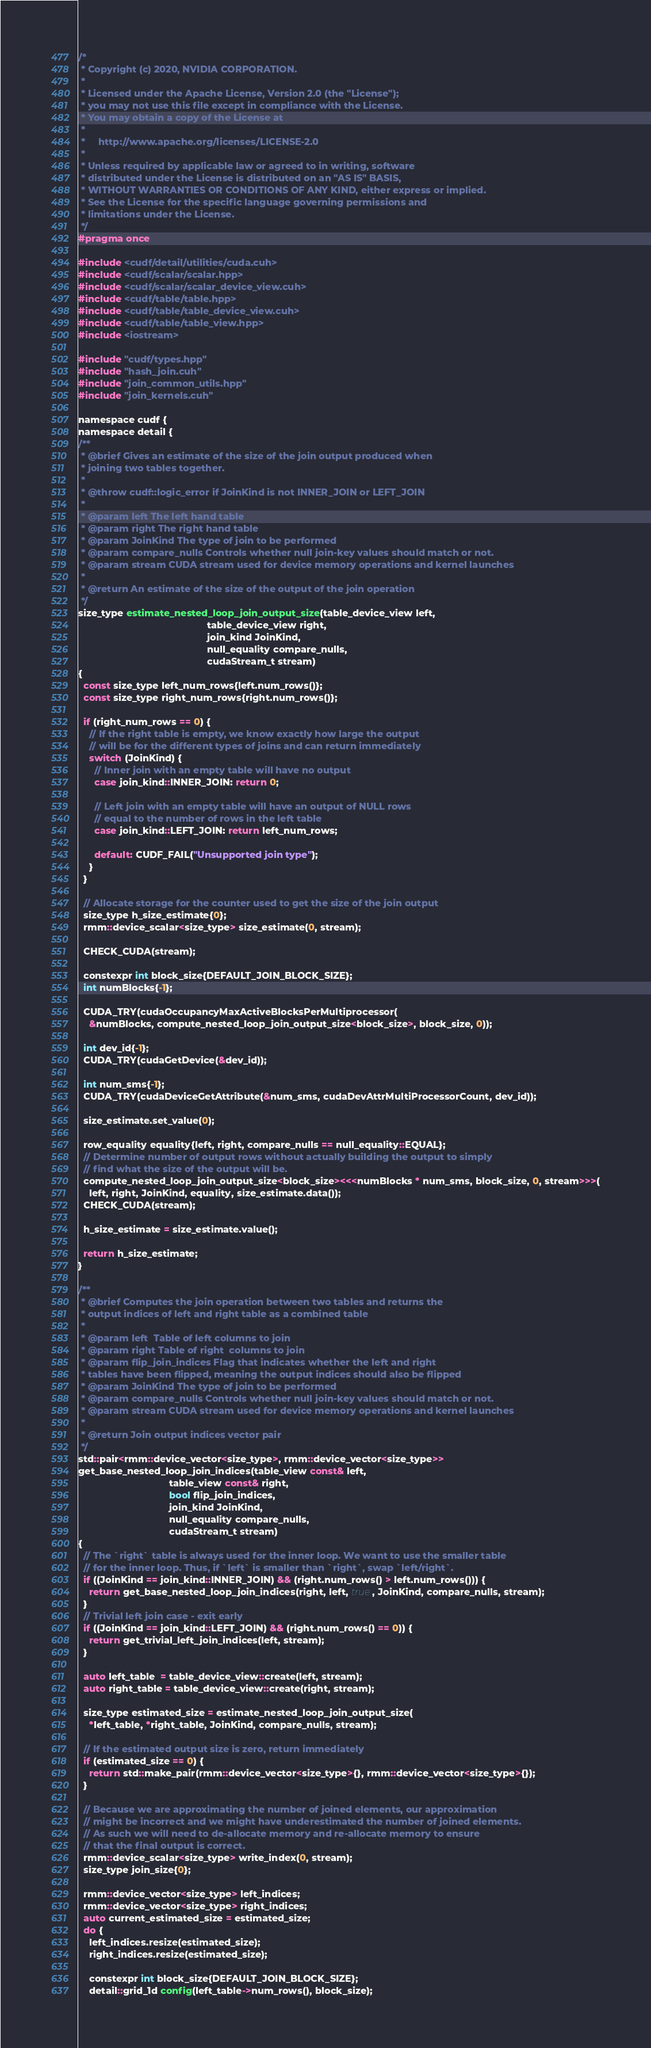Convert code to text. <code><loc_0><loc_0><loc_500><loc_500><_Cuda_>/*
 * Copyright (c) 2020, NVIDIA CORPORATION.
 *
 * Licensed under the Apache License, Version 2.0 (the "License");
 * you may not use this file except in compliance with the License.
 * You may obtain a copy of the License at
 *
 *     http://www.apache.org/licenses/LICENSE-2.0
 *
 * Unless required by applicable law or agreed to in writing, software
 * distributed under the License is distributed on an "AS IS" BASIS,
 * WITHOUT WARRANTIES OR CONDITIONS OF ANY KIND, either express or implied.
 * See the License for the specific language governing permissions and
 * limitations under the License.
 */
#pragma once

#include <cudf/detail/utilities/cuda.cuh>
#include <cudf/scalar/scalar.hpp>
#include <cudf/scalar/scalar_device_view.cuh>
#include <cudf/table/table.hpp>
#include <cudf/table/table_device_view.cuh>
#include <cudf/table/table_view.hpp>
#include <iostream>

#include "cudf/types.hpp"
#include "hash_join.cuh"
#include "join_common_utils.hpp"
#include "join_kernels.cuh"

namespace cudf {
namespace detail {
/**
 * @brief Gives an estimate of the size of the join output produced when
 * joining two tables together.
 *
 * @throw cudf::logic_error if JoinKind is not INNER_JOIN or LEFT_JOIN
 *
 * @param left The left hand table
 * @param right The right hand table
 * @param JoinKind The type of join to be performed
 * @param compare_nulls Controls whether null join-key values should match or not.
 * @param stream CUDA stream used for device memory operations and kernel launches
 *
 * @return An estimate of the size of the output of the join operation
 */
size_type estimate_nested_loop_join_output_size(table_device_view left,
                                                table_device_view right,
                                                join_kind JoinKind,
                                                null_equality compare_nulls,
                                                cudaStream_t stream)
{
  const size_type left_num_rows{left.num_rows()};
  const size_type right_num_rows{right.num_rows()};

  if (right_num_rows == 0) {
    // If the right table is empty, we know exactly how large the output
    // will be for the different types of joins and can return immediately
    switch (JoinKind) {
      // Inner join with an empty table will have no output
      case join_kind::INNER_JOIN: return 0;

      // Left join with an empty table will have an output of NULL rows
      // equal to the number of rows in the left table
      case join_kind::LEFT_JOIN: return left_num_rows;

      default: CUDF_FAIL("Unsupported join type");
    }
  }

  // Allocate storage for the counter used to get the size of the join output
  size_type h_size_estimate{0};
  rmm::device_scalar<size_type> size_estimate(0, stream);

  CHECK_CUDA(stream);

  constexpr int block_size{DEFAULT_JOIN_BLOCK_SIZE};
  int numBlocks{-1};

  CUDA_TRY(cudaOccupancyMaxActiveBlocksPerMultiprocessor(
    &numBlocks, compute_nested_loop_join_output_size<block_size>, block_size, 0));

  int dev_id{-1};
  CUDA_TRY(cudaGetDevice(&dev_id));

  int num_sms{-1};
  CUDA_TRY(cudaDeviceGetAttribute(&num_sms, cudaDevAttrMultiProcessorCount, dev_id));

  size_estimate.set_value(0);

  row_equality equality{left, right, compare_nulls == null_equality::EQUAL};
  // Determine number of output rows without actually building the output to simply
  // find what the size of the output will be.
  compute_nested_loop_join_output_size<block_size><<<numBlocks * num_sms, block_size, 0, stream>>>(
    left, right, JoinKind, equality, size_estimate.data());
  CHECK_CUDA(stream);

  h_size_estimate = size_estimate.value();

  return h_size_estimate;
}

/**
 * @brief Computes the join operation between two tables and returns the
 * output indices of left and right table as a combined table
 *
 * @param left  Table of left columns to join
 * @param right Table of right  columns to join
 * @param flip_join_indices Flag that indicates whether the left and right
 * tables have been flipped, meaning the output indices should also be flipped
 * @param JoinKind The type of join to be performed
 * @param compare_nulls Controls whether null join-key values should match or not.
 * @param stream CUDA stream used for device memory operations and kernel launches
 *
 * @return Join output indices vector pair
 */
std::pair<rmm::device_vector<size_type>, rmm::device_vector<size_type>>
get_base_nested_loop_join_indices(table_view const& left,
                                  table_view const& right,
                                  bool flip_join_indices,
                                  join_kind JoinKind,
                                  null_equality compare_nulls,
                                  cudaStream_t stream)
{
  // The `right` table is always used for the inner loop. We want to use the smaller table
  // for the inner loop. Thus, if `left` is smaller than `right`, swap `left/right`.
  if ((JoinKind == join_kind::INNER_JOIN) && (right.num_rows() > left.num_rows())) {
    return get_base_nested_loop_join_indices(right, left, true, JoinKind, compare_nulls, stream);
  }
  // Trivial left join case - exit early
  if ((JoinKind == join_kind::LEFT_JOIN) && (right.num_rows() == 0)) {
    return get_trivial_left_join_indices(left, stream);
  }

  auto left_table  = table_device_view::create(left, stream);
  auto right_table = table_device_view::create(right, stream);

  size_type estimated_size = estimate_nested_loop_join_output_size(
    *left_table, *right_table, JoinKind, compare_nulls, stream);

  // If the estimated output size is zero, return immediately
  if (estimated_size == 0) {
    return std::make_pair(rmm::device_vector<size_type>{}, rmm::device_vector<size_type>{});
  }

  // Because we are approximating the number of joined elements, our approximation
  // might be incorrect and we might have underestimated the number of joined elements.
  // As such we will need to de-allocate memory and re-allocate memory to ensure
  // that the final output is correct.
  rmm::device_scalar<size_type> write_index(0, stream);
  size_type join_size{0};

  rmm::device_vector<size_type> left_indices;
  rmm::device_vector<size_type> right_indices;
  auto current_estimated_size = estimated_size;
  do {
    left_indices.resize(estimated_size);
    right_indices.resize(estimated_size);

    constexpr int block_size{DEFAULT_JOIN_BLOCK_SIZE};
    detail::grid_1d config(left_table->num_rows(), block_size);</code> 